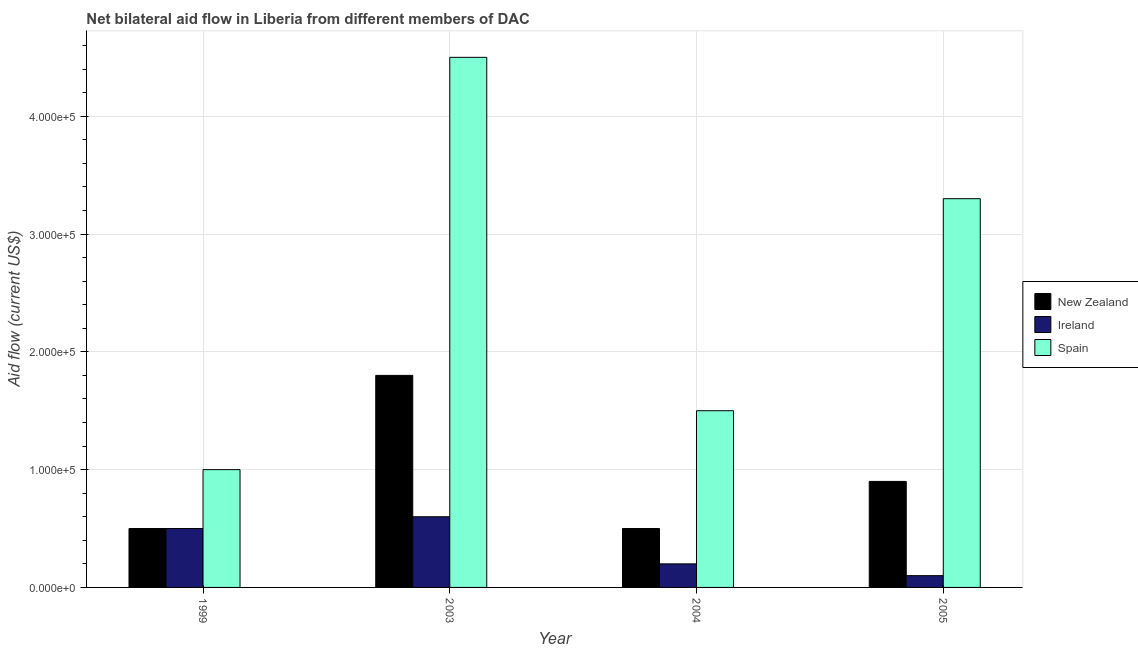How many groups of bars are there?
Keep it short and to the point. 4. Are the number of bars per tick equal to the number of legend labels?
Give a very brief answer. Yes. Are the number of bars on each tick of the X-axis equal?
Provide a short and direct response. Yes. How many bars are there on the 1st tick from the left?
Give a very brief answer. 3. What is the label of the 4th group of bars from the left?
Ensure brevity in your answer.  2005. What is the amount of aid provided by new zealand in 2005?
Your answer should be compact. 9.00e+04. Across all years, what is the maximum amount of aid provided by spain?
Offer a very short reply. 4.50e+05. Across all years, what is the minimum amount of aid provided by ireland?
Provide a short and direct response. 10000. In which year was the amount of aid provided by spain maximum?
Provide a succinct answer. 2003. What is the total amount of aid provided by new zealand in the graph?
Provide a short and direct response. 3.70e+05. What is the difference between the amount of aid provided by ireland in 1999 and that in 2003?
Your answer should be compact. -10000. What is the difference between the amount of aid provided by new zealand in 2003 and the amount of aid provided by ireland in 2004?
Offer a terse response. 1.30e+05. What is the average amount of aid provided by new zealand per year?
Give a very brief answer. 9.25e+04. In the year 2004, what is the difference between the amount of aid provided by new zealand and amount of aid provided by spain?
Your answer should be compact. 0. In how many years, is the amount of aid provided by ireland greater than 200000 US$?
Provide a succinct answer. 0. Is the difference between the amount of aid provided by spain in 1999 and 2005 greater than the difference between the amount of aid provided by new zealand in 1999 and 2005?
Provide a short and direct response. No. What is the difference between the highest and the lowest amount of aid provided by spain?
Offer a terse response. 3.50e+05. In how many years, is the amount of aid provided by new zealand greater than the average amount of aid provided by new zealand taken over all years?
Make the answer very short. 1. Is the sum of the amount of aid provided by new zealand in 1999 and 2004 greater than the maximum amount of aid provided by spain across all years?
Your answer should be very brief. No. What does the 3rd bar from the left in 2003 represents?
Provide a succinct answer. Spain. What does the 3rd bar from the right in 2003 represents?
Offer a very short reply. New Zealand. Are all the bars in the graph horizontal?
Your answer should be very brief. No. How many years are there in the graph?
Offer a terse response. 4. Are the values on the major ticks of Y-axis written in scientific E-notation?
Your answer should be very brief. Yes. Does the graph contain any zero values?
Provide a short and direct response. No. Does the graph contain grids?
Give a very brief answer. Yes. What is the title of the graph?
Give a very brief answer. Net bilateral aid flow in Liberia from different members of DAC. Does "Ages 20-60" appear as one of the legend labels in the graph?
Make the answer very short. No. What is the label or title of the Y-axis?
Provide a succinct answer. Aid flow (current US$). What is the Aid flow (current US$) of Ireland in 2003?
Give a very brief answer. 6.00e+04. What is the Aid flow (current US$) in Ireland in 2004?
Make the answer very short. 2.00e+04. What is the Aid flow (current US$) in Spain in 2004?
Your response must be concise. 1.50e+05. What is the Aid flow (current US$) in Ireland in 2005?
Ensure brevity in your answer.  10000. What is the Aid flow (current US$) in Spain in 2005?
Provide a short and direct response. 3.30e+05. Across all years, what is the maximum Aid flow (current US$) in New Zealand?
Your answer should be very brief. 1.80e+05. Across all years, what is the minimum Aid flow (current US$) in New Zealand?
Your response must be concise. 5.00e+04. Across all years, what is the minimum Aid flow (current US$) of Ireland?
Your answer should be very brief. 10000. Across all years, what is the minimum Aid flow (current US$) of Spain?
Your response must be concise. 1.00e+05. What is the total Aid flow (current US$) in Spain in the graph?
Your response must be concise. 1.03e+06. What is the difference between the Aid flow (current US$) in New Zealand in 1999 and that in 2003?
Your answer should be compact. -1.30e+05. What is the difference between the Aid flow (current US$) in Spain in 1999 and that in 2003?
Your answer should be compact. -3.50e+05. What is the difference between the Aid flow (current US$) in Spain in 1999 and that in 2004?
Offer a very short reply. -5.00e+04. What is the difference between the Aid flow (current US$) of New Zealand in 1999 and that in 2005?
Ensure brevity in your answer.  -4.00e+04. What is the difference between the Aid flow (current US$) of Ireland in 1999 and that in 2005?
Provide a succinct answer. 4.00e+04. What is the difference between the Aid flow (current US$) in Spain in 1999 and that in 2005?
Provide a succinct answer. -2.30e+05. What is the difference between the Aid flow (current US$) of New Zealand in 2003 and that in 2004?
Your answer should be compact. 1.30e+05. What is the difference between the Aid flow (current US$) in Spain in 2003 and that in 2004?
Keep it short and to the point. 3.00e+05. What is the difference between the Aid flow (current US$) in New Zealand in 2003 and that in 2005?
Your response must be concise. 9.00e+04. What is the difference between the Aid flow (current US$) of Ireland in 2003 and that in 2005?
Provide a succinct answer. 5.00e+04. What is the difference between the Aid flow (current US$) in Spain in 2003 and that in 2005?
Make the answer very short. 1.20e+05. What is the difference between the Aid flow (current US$) of Ireland in 2004 and that in 2005?
Your answer should be very brief. 10000. What is the difference between the Aid flow (current US$) in Spain in 2004 and that in 2005?
Your answer should be very brief. -1.80e+05. What is the difference between the Aid flow (current US$) in New Zealand in 1999 and the Aid flow (current US$) in Ireland in 2003?
Provide a short and direct response. -10000. What is the difference between the Aid flow (current US$) of New Zealand in 1999 and the Aid flow (current US$) of Spain in 2003?
Provide a short and direct response. -4.00e+05. What is the difference between the Aid flow (current US$) of Ireland in 1999 and the Aid flow (current US$) of Spain in 2003?
Ensure brevity in your answer.  -4.00e+05. What is the difference between the Aid flow (current US$) in New Zealand in 1999 and the Aid flow (current US$) in Spain in 2004?
Offer a terse response. -1.00e+05. What is the difference between the Aid flow (current US$) of Ireland in 1999 and the Aid flow (current US$) of Spain in 2004?
Provide a succinct answer. -1.00e+05. What is the difference between the Aid flow (current US$) of New Zealand in 1999 and the Aid flow (current US$) of Ireland in 2005?
Keep it short and to the point. 4.00e+04. What is the difference between the Aid flow (current US$) of New Zealand in 1999 and the Aid flow (current US$) of Spain in 2005?
Keep it short and to the point. -2.80e+05. What is the difference between the Aid flow (current US$) of Ireland in 1999 and the Aid flow (current US$) of Spain in 2005?
Your answer should be compact. -2.80e+05. What is the difference between the Aid flow (current US$) in New Zealand in 2003 and the Aid flow (current US$) in Ireland in 2004?
Offer a terse response. 1.60e+05. What is the difference between the Aid flow (current US$) in Ireland in 2003 and the Aid flow (current US$) in Spain in 2004?
Give a very brief answer. -9.00e+04. What is the difference between the Aid flow (current US$) in New Zealand in 2003 and the Aid flow (current US$) in Ireland in 2005?
Your answer should be very brief. 1.70e+05. What is the difference between the Aid flow (current US$) in New Zealand in 2003 and the Aid flow (current US$) in Spain in 2005?
Give a very brief answer. -1.50e+05. What is the difference between the Aid flow (current US$) of Ireland in 2003 and the Aid flow (current US$) of Spain in 2005?
Your answer should be compact. -2.70e+05. What is the difference between the Aid flow (current US$) in New Zealand in 2004 and the Aid flow (current US$) in Ireland in 2005?
Your response must be concise. 4.00e+04. What is the difference between the Aid flow (current US$) of New Zealand in 2004 and the Aid flow (current US$) of Spain in 2005?
Make the answer very short. -2.80e+05. What is the difference between the Aid flow (current US$) in Ireland in 2004 and the Aid flow (current US$) in Spain in 2005?
Offer a terse response. -3.10e+05. What is the average Aid flow (current US$) in New Zealand per year?
Keep it short and to the point. 9.25e+04. What is the average Aid flow (current US$) in Ireland per year?
Offer a terse response. 3.50e+04. What is the average Aid flow (current US$) in Spain per year?
Provide a succinct answer. 2.58e+05. In the year 1999, what is the difference between the Aid flow (current US$) of New Zealand and Aid flow (current US$) of Ireland?
Ensure brevity in your answer.  0. In the year 1999, what is the difference between the Aid flow (current US$) of Ireland and Aid flow (current US$) of Spain?
Make the answer very short. -5.00e+04. In the year 2003, what is the difference between the Aid flow (current US$) in New Zealand and Aid flow (current US$) in Ireland?
Provide a short and direct response. 1.20e+05. In the year 2003, what is the difference between the Aid flow (current US$) of New Zealand and Aid flow (current US$) of Spain?
Offer a very short reply. -2.70e+05. In the year 2003, what is the difference between the Aid flow (current US$) in Ireland and Aid flow (current US$) in Spain?
Provide a succinct answer. -3.90e+05. In the year 2004, what is the difference between the Aid flow (current US$) in New Zealand and Aid flow (current US$) in Spain?
Give a very brief answer. -1.00e+05. In the year 2004, what is the difference between the Aid flow (current US$) in Ireland and Aid flow (current US$) in Spain?
Your answer should be very brief. -1.30e+05. In the year 2005, what is the difference between the Aid flow (current US$) in New Zealand and Aid flow (current US$) in Ireland?
Your response must be concise. 8.00e+04. In the year 2005, what is the difference between the Aid flow (current US$) of Ireland and Aid flow (current US$) of Spain?
Your response must be concise. -3.20e+05. What is the ratio of the Aid flow (current US$) in New Zealand in 1999 to that in 2003?
Your response must be concise. 0.28. What is the ratio of the Aid flow (current US$) of Ireland in 1999 to that in 2003?
Provide a short and direct response. 0.83. What is the ratio of the Aid flow (current US$) of Spain in 1999 to that in 2003?
Your response must be concise. 0.22. What is the ratio of the Aid flow (current US$) in Ireland in 1999 to that in 2004?
Your answer should be very brief. 2.5. What is the ratio of the Aid flow (current US$) in New Zealand in 1999 to that in 2005?
Provide a succinct answer. 0.56. What is the ratio of the Aid flow (current US$) in Spain in 1999 to that in 2005?
Give a very brief answer. 0.3. What is the ratio of the Aid flow (current US$) of New Zealand in 2003 to that in 2004?
Your response must be concise. 3.6. What is the ratio of the Aid flow (current US$) in Ireland in 2003 to that in 2004?
Provide a succinct answer. 3. What is the ratio of the Aid flow (current US$) in Spain in 2003 to that in 2004?
Your answer should be compact. 3. What is the ratio of the Aid flow (current US$) in New Zealand in 2003 to that in 2005?
Offer a terse response. 2. What is the ratio of the Aid flow (current US$) of Spain in 2003 to that in 2005?
Provide a short and direct response. 1.36. What is the ratio of the Aid flow (current US$) of New Zealand in 2004 to that in 2005?
Provide a short and direct response. 0.56. What is the ratio of the Aid flow (current US$) of Ireland in 2004 to that in 2005?
Your answer should be compact. 2. What is the ratio of the Aid flow (current US$) of Spain in 2004 to that in 2005?
Offer a very short reply. 0.45. What is the difference between the highest and the second highest Aid flow (current US$) in New Zealand?
Your answer should be very brief. 9.00e+04. What is the difference between the highest and the second highest Aid flow (current US$) of Ireland?
Make the answer very short. 10000. What is the difference between the highest and the second highest Aid flow (current US$) of Spain?
Keep it short and to the point. 1.20e+05. What is the difference between the highest and the lowest Aid flow (current US$) in Ireland?
Offer a very short reply. 5.00e+04. What is the difference between the highest and the lowest Aid flow (current US$) of Spain?
Give a very brief answer. 3.50e+05. 